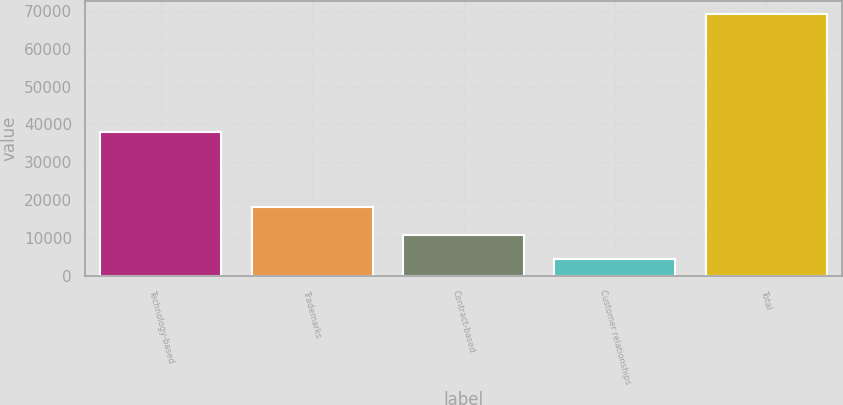<chart> <loc_0><loc_0><loc_500><loc_500><bar_chart><fcel>Technology-based<fcel>Trademarks<fcel>Contract-based<fcel>Customer relationships<fcel>Total<nl><fcel>38066<fcel>18236<fcel>10789.2<fcel>4294<fcel>69246<nl></chart> 